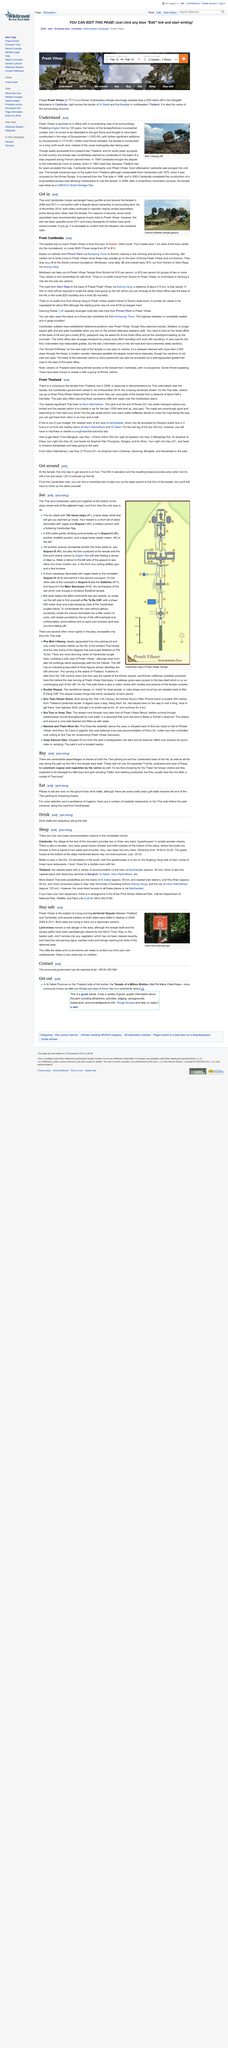Outline some significant characteristics in this image. In 2008, Preah Vihear was listed as a UNESCO World Heritage Site. Preah Vihear is dedicated to the god Shiva. The gopura temple site has been peaceful since 2011, as evidenced by the lack of violent incidents at the site. The photograph shows a temple gopura. Preah Vihear was constructed during the reign of Suryavarman 1, who ruled from 1002 to 1050. It is believed to have been constructed during this time period. 